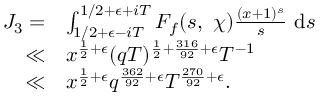Convert formula to latex. <formula><loc_0><loc_0><loc_500><loc_500>\begin{array} { r l } { J _ { 3 } = } & { \int _ { 1 / 2 + \epsilon - i T } ^ { 1 / 2 + \epsilon + i T } F _ { f } ( s , \ \chi ) \frac { ( x + 1 ) ^ { s } } { s } \ d s } \\ { \ll } & { x ^ { \frac { 1 } { 2 } + \epsilon } ( q T ) ^ { \frac { 1 } { 2 } + \frac { 3 1 6 } { 9 2 } + \epsilon } T ^ { - 1 } } \\ { \ll } & { x ^ { \frac { 1 } { 2 } + \epsilon } q ^ { \frac { 3 6 2 } { 9 2 } + \epsilon } T ^ { \frac { 2 7 0 } { 9 2 } + \epsilon } . } \end{array}</formula> 